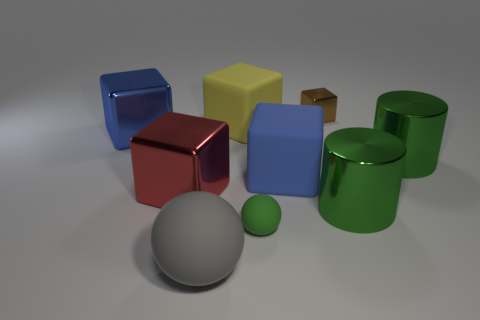Subtract all gray spheres. How many spheres are left? 1 Subtract all big red blocks. How many blocks are left? 4 Subtract all cylinders. How many objects are left? 7 Subtract all brown balls. Subtract all blue cylinders. How many balls are left? 2 Subtract all gray cylinders. How many green spheres are left? 1 Subtract all brown rubber cubes. Subtract all rubber spheres. How many objects are left? 7 Add 6 big blue objects. How many big blue objects are left? 8 Add 7 yellow metal blocks. How many yellow metal blocks exist? 7 Subtract 0 gray blocks. How many objects are left? 9 Subtract 3 cubes. How many cubes are left? 2 